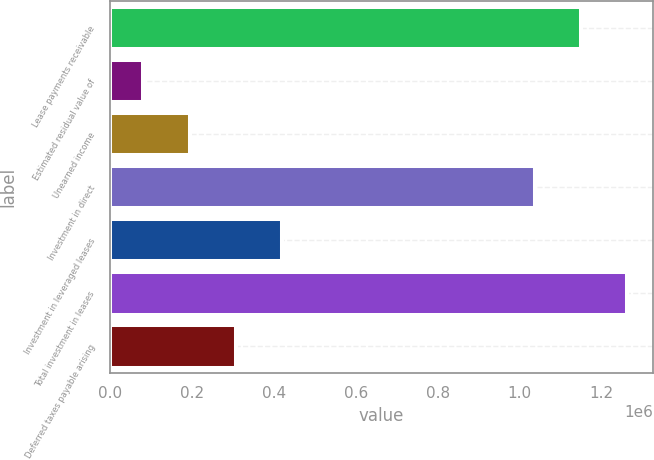Convert chart. <chart><loc_0><loc_0><loc_500><loc_500><bar_chart><fcel>Lease payments receivable<fcel>Estimated residual value of<fcel>Unearned income<fcel>Investment in direct<fcel>Investment in leveraged leases<fcel>Total investment in leases<fcel>Deferred taxes payable arising<nl><fcel>1.14993e+06<fcel>81269<fcel>194046<fcel>1.03715e+06<fcel>419600<fcel>1.2627e+06<fcel>306823<nl></chart> 